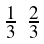<formula> <loc_0><loc_0><loc_500><loc_500>\begin{smallmatrix} \frac { 1 } { 3 } & \frac { 2 } { 3 } \end{smallmatrix}</formula> 